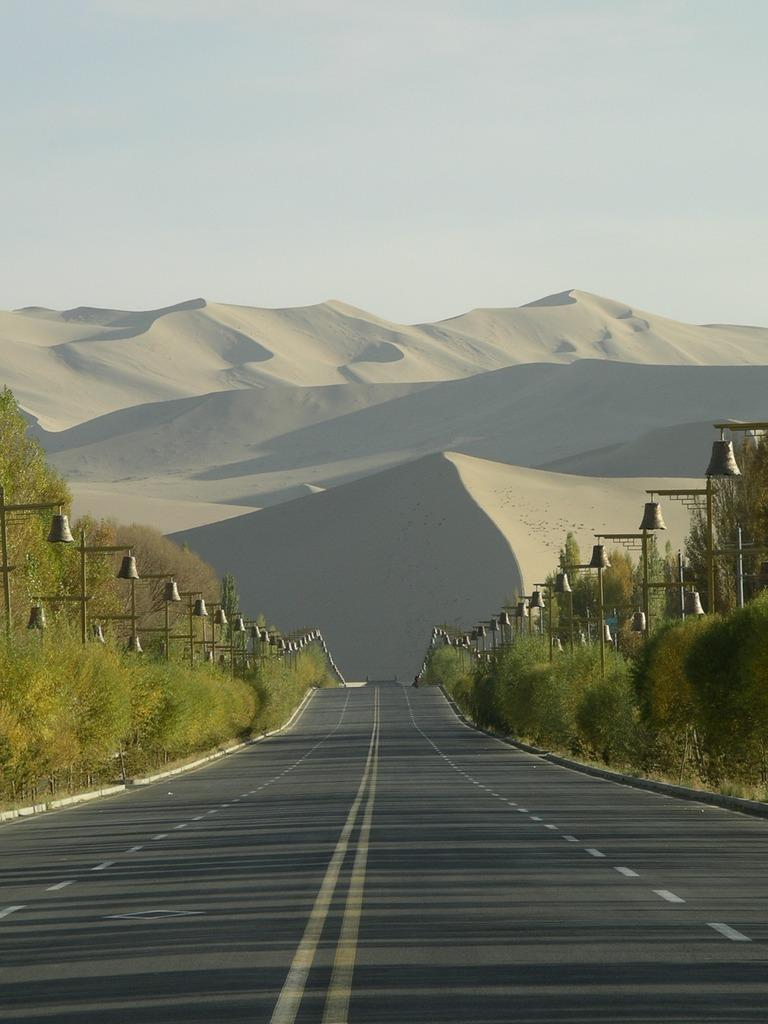What is the main feature of the image? There is a road in the image. What can be seen on both sides of the road? There are trees on either side of the road. What is visible in the background of the image? Bells, sand, and the sky are visible in the background of the image. How many queens are present in the image? There are no queens present in the image. What is the amount of sand visible in the image? The amount of sand visible in the image cannot be determined from the provided facts. 